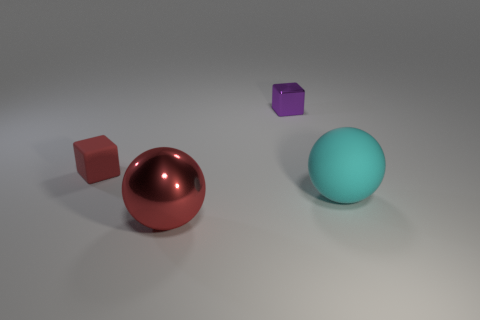Add 2 small yellow metallic objects. How many objects exist? 6 Subtract 0 green cubes. How many objects are left? 4 Subtract all metal balls. Subtract all small red rubber blocks. How many objects are left? 2 Add 1 cyan objects. How many cyan objects are left? 2 Add 2 shiny blocks. How many shiny blocks exist? 3 